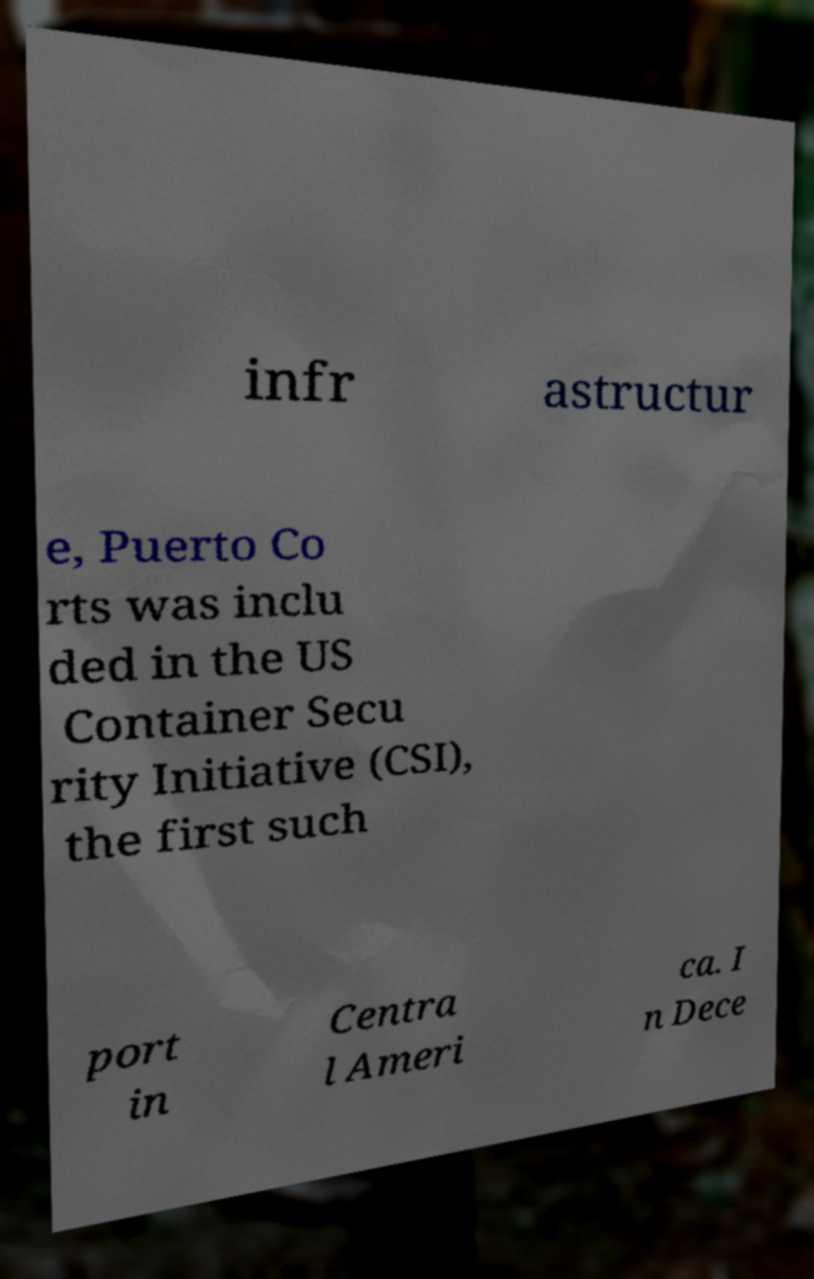Can you read and provide the text displayed in the image?This photo seems to have some interesting text. Can you extract and type it out for me? infr astructur e, Puerto Co rts was inclu ded in the US Container Secu rity Initiative (CSI), the first such port in Centra l Ameri ca. I n Dece 